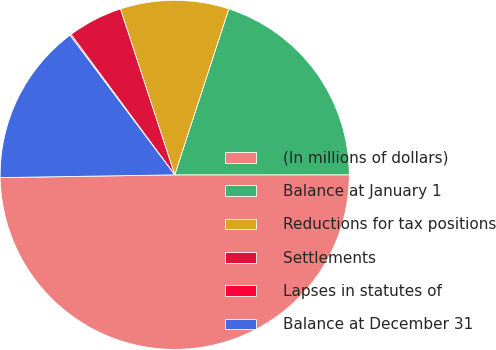Convert chart to OTSL. <chart><loc_0><loc_0><loc_500><loc_500><pie_chart><fcel>(In millions of dollars)<fcel>Balance at January 1<fcel>Reductions for tax positions<fcel>Settlements<fcel>Lapses in statutes of<fcel>Balance at December 31<nl><fcel>49.75%<fcel>19.98%<fcel>10.05%<fcel>5.09%<fcel>0.12%<fcel>15.01%<nl></chart> 